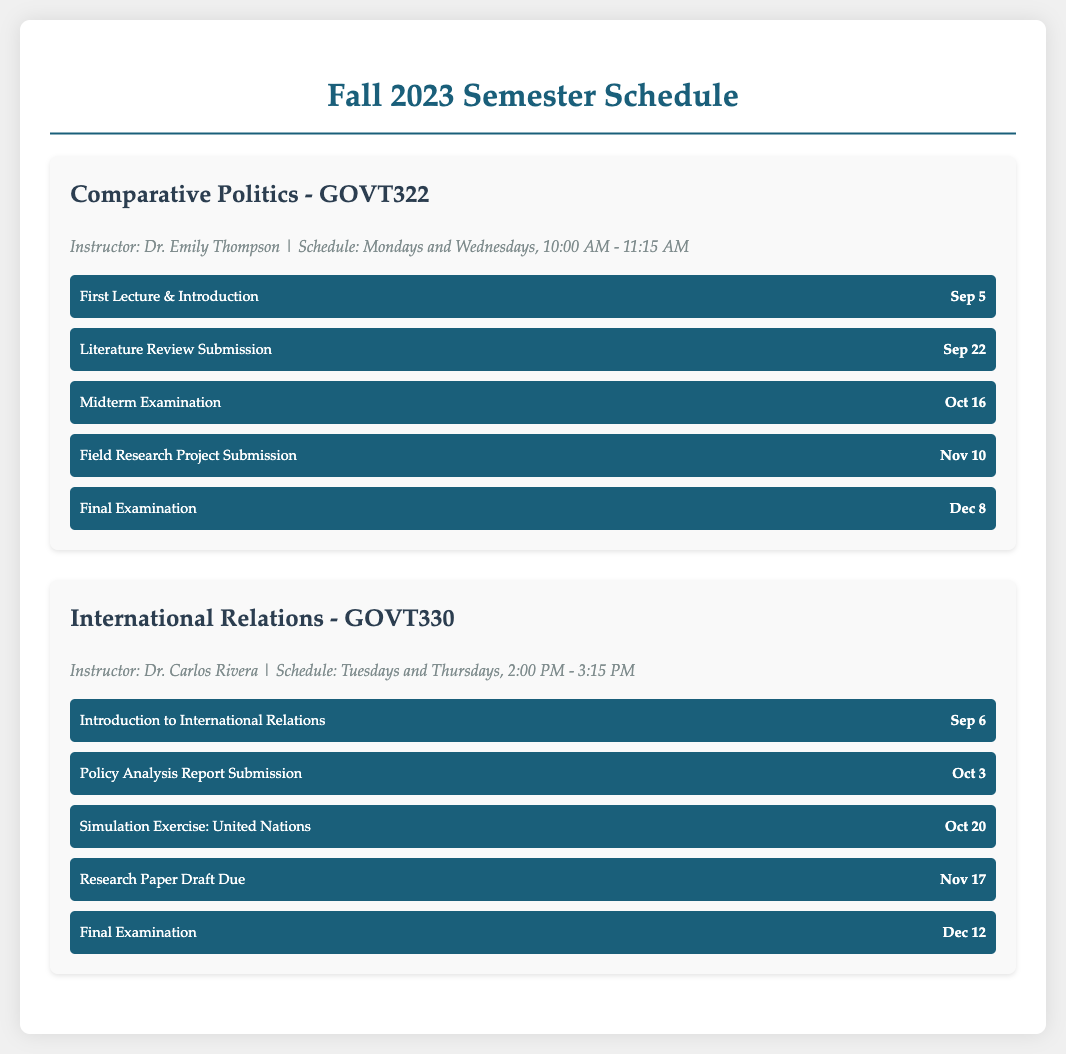What is the course code for Comparative Politics? The course code for Comparative Politics is specified in the document.
Answer: GOVT322 Who is the instructor for International Relations? The instructor's name for International Relations can be found in the course information section.
Answer: Dr. Carlos Rivera When is the Literature Review Submission due for Comparative Politics? The due date for the Literature Review Submission is listed under the milestones for Comparative Politics.
Answer: Sep 22 How many midterm examinations are listed in the document? The document mentions one midterm examination for each course.
Answer: 2 What is the date of the final examination for International Relations? The final examination date is provided in the milestones for International Relations.
Answer: Dec 12 What day of the week is Comparative Politics scheduled? The schedule days for Comparative Politics are mentioned in the course information.
Answer: Mondays and Wednesdays What milestone is due on Nov 10 for Comparative Politics? The milestone due on Nov 10 is listed under the key milestones for Comparative Politics.
Answer: Field Research Project Submission How many total milestones are there for International Relations? The number of milestones for International Relations can be counted from the document.
Answer: 5 When is the first lecture for Comparative Politics? The date of the first lecture is specified in the milestones section for Comparative Politics.
Answer: Sep 5 